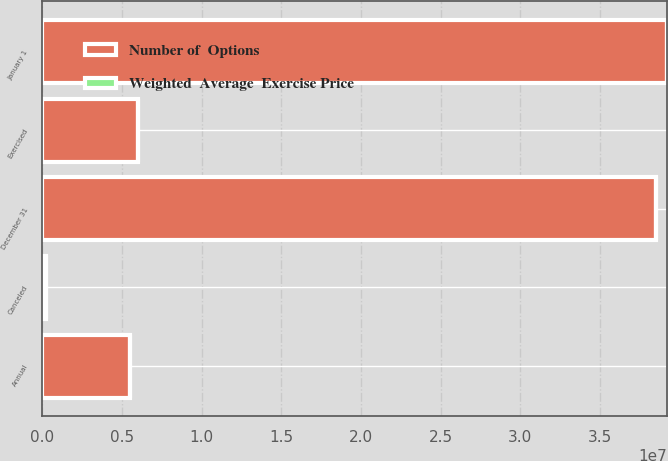Convert chart to OTSL. <chart><loc_0><loc_0><loc_500><loc_500><stacked_bar_chart><ecel><fcel>January 1<fcel>Annual<fcel>Exercised<fcel>Canceled<fcel>December 31<nl><fcel>Number of  Options<fcel>3.92356e+07<fcel>5.52954e+06<fcel>5.97838e+06<fcel>234274<fcel>3.85524e+07<nl><fcel>Weighted  Average  Exercise Price<fcel>90.38<fcel>165.91<fcel>83.74<fcel>128.99<fcel>102.01<nl></chart> 